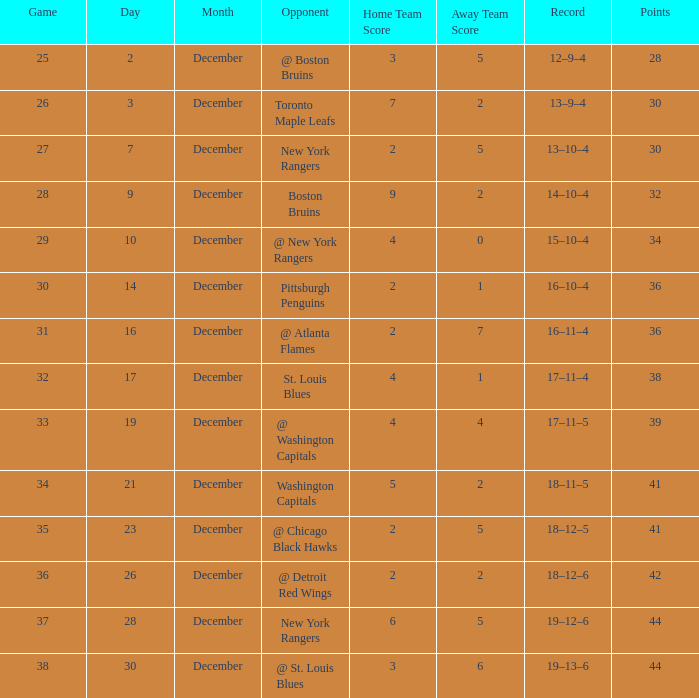Could you parse the entire table? {'header': ['Game', 'Day', 'Month', 'Opponent', 'Home Team Score', 'Away Team Score', 'Record', 'Points'], 'rows': [['25', '2', 'December', '@ Boston Bruins', '3', '5', '12–9–4', '28'], ['26', '3', 'December', 'Toronto Maple Leafs', '7', '2', '13–9–4', '30'], ['27', '7', 'December', 'New York Rangers', '2', '5', '13–10–4', '30'], ['28', '9', 'December', 'Boston Bruins', '9', '2', '14–10–4', '32'], ['29', '10', 'December', '@ New York Rangers', '4', '0', '15–10–4', '34'], ['30', '14', 'December', 'Pittsburgh Penguins', '2', '1', '16–10–4', '36'], ['31', '16', 'December', '@ Atlanta Flames', '2', '7', '16–11–4', '36'], ['32', '17', 'December', 'St. Louis Blues', '4', '1', '17–11–4', '38'], ['33', '19', 'December', '@ Washington Capitals', '4', '4', '17–11–5', '39'], ['34', '21', 'December', 'Washington Capitals', '5', '2', '18–11–5', '41'], ['35', '23', 'December', '@ Chicago Black Hawks', '2', '5', '18–12–5', '41'], ['36', '26', 'December', '@ Detroit Red Wings', '2', '2', '18–12–6', '42'], ['37', '28', 'December', 'New York Rangers', '6', '5', '19–12–6', '44'], ['38', '30', 'December', '@ St. Louis Blues', '3', '6', '19–13–6', '44']]} Which Score has a Game larger than 32, and Points smaller than 42, and a December larger than 19, and a Record of 18–12–5? 2–5. 